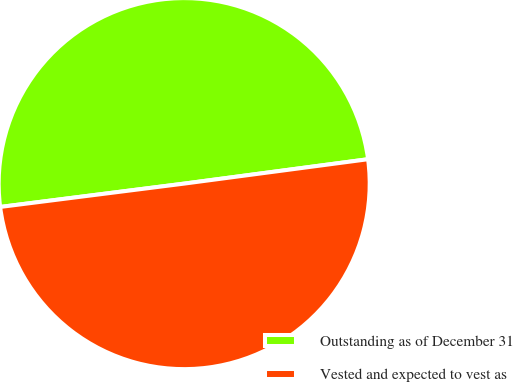Convert chart to OTSL. <chart><loc_0><loc_0><loc_500><loc_500><pie_chart><fcel>Outstanding as of December 31<fcel>Vested and expected to vest as<nl><fcel>49.91%<fcel>50.09%<nl></chart> 